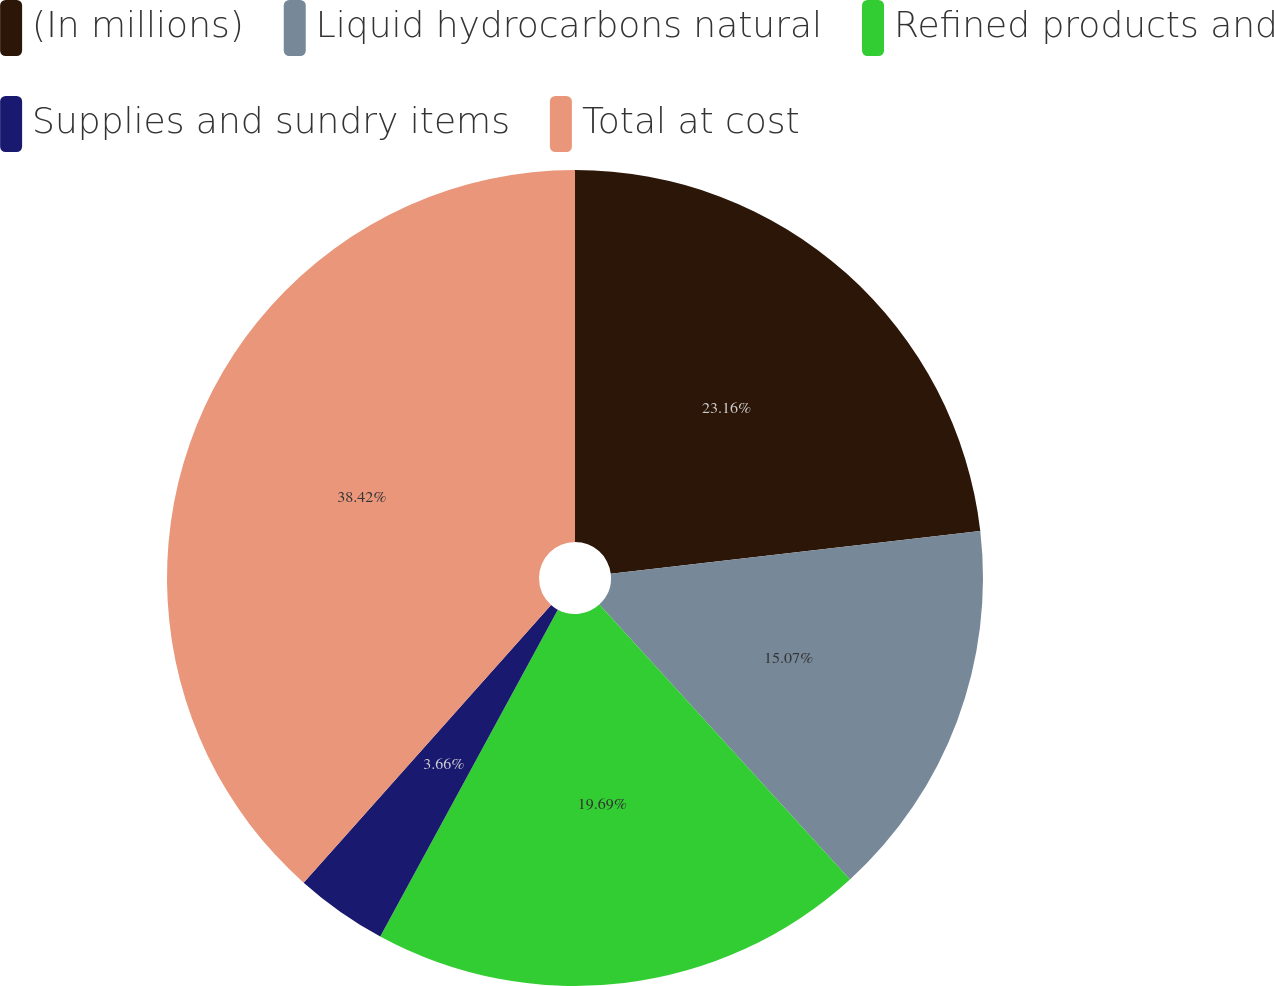Convert chart to OTSL. <chart><loc_0><loc_0><loc_500><loc_500><pie_chart><fcel>(In millions)<fcel>Liquid hydrocarbons natural<fcel>Refined products and<fcel>Supplies and sundry items<fcel>Total at cost<nl><fcel>23.16%<fcel>15.07%<fcel>19.69%<fcel>3.66%<fcel>38.42%<nl></chart> 